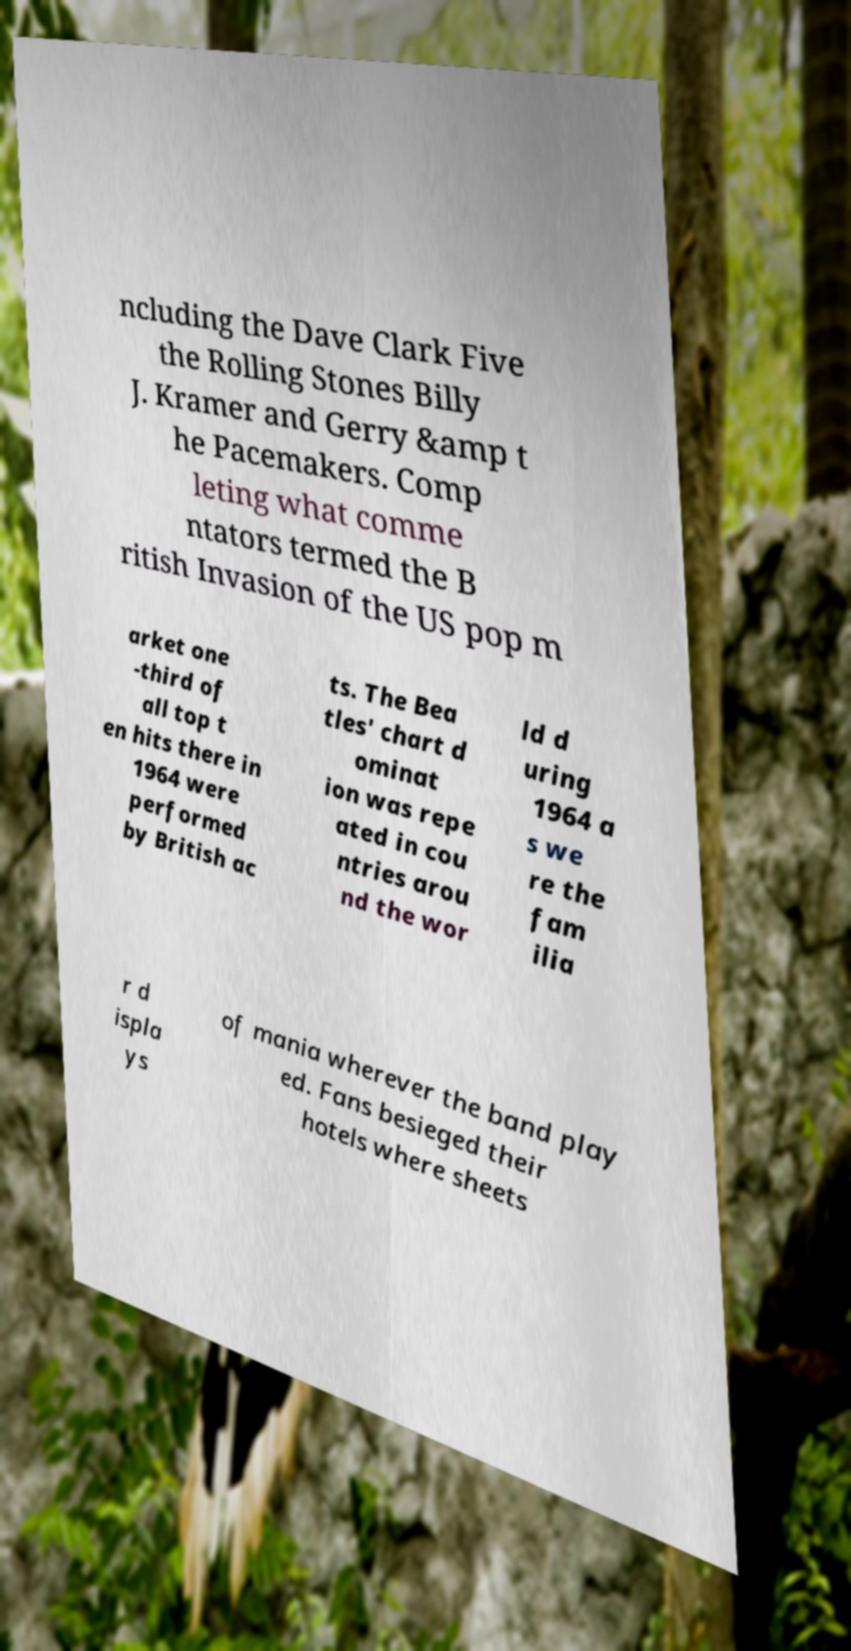Please identify and transcribe the text found in this image. ncluding the Dave Clark Five the Rolling Stones Billy J. Kramer and Gerry &amp t he Pacemakers. Comp leting what comme ntators termed the B ritish Invasion of the US pop m arket one -third of all top t en hits there in 1964 were performed by British ac ts. The Bea tles' chart d ominat ion was repe ated in cou ntries arou nd the wor ld d uring 1964 a s we re the fam ilia r d ispla ys of mania wherever the band play ed. Fans besieged their hotels where sheets 